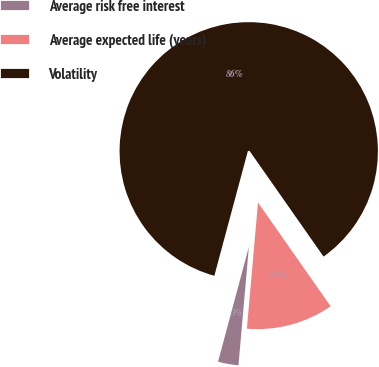<chart> <loc_0><loc_0><loc_500><loc_500><pie_chart><fcel>Average risk free interest<fcel>Average expected life (years)<fcel>Volatility<nl><fcel>2.78%<fcel>11.12%<fcel>86.1%<nl></chart> 